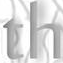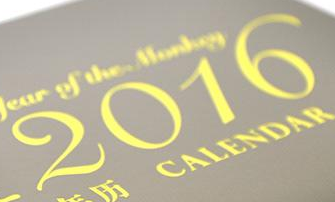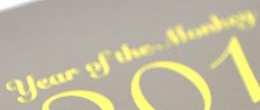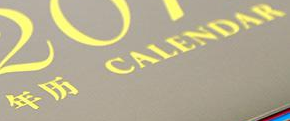What text appears in these images from left to right, separated by a semicolon? th; 2016; #; # 